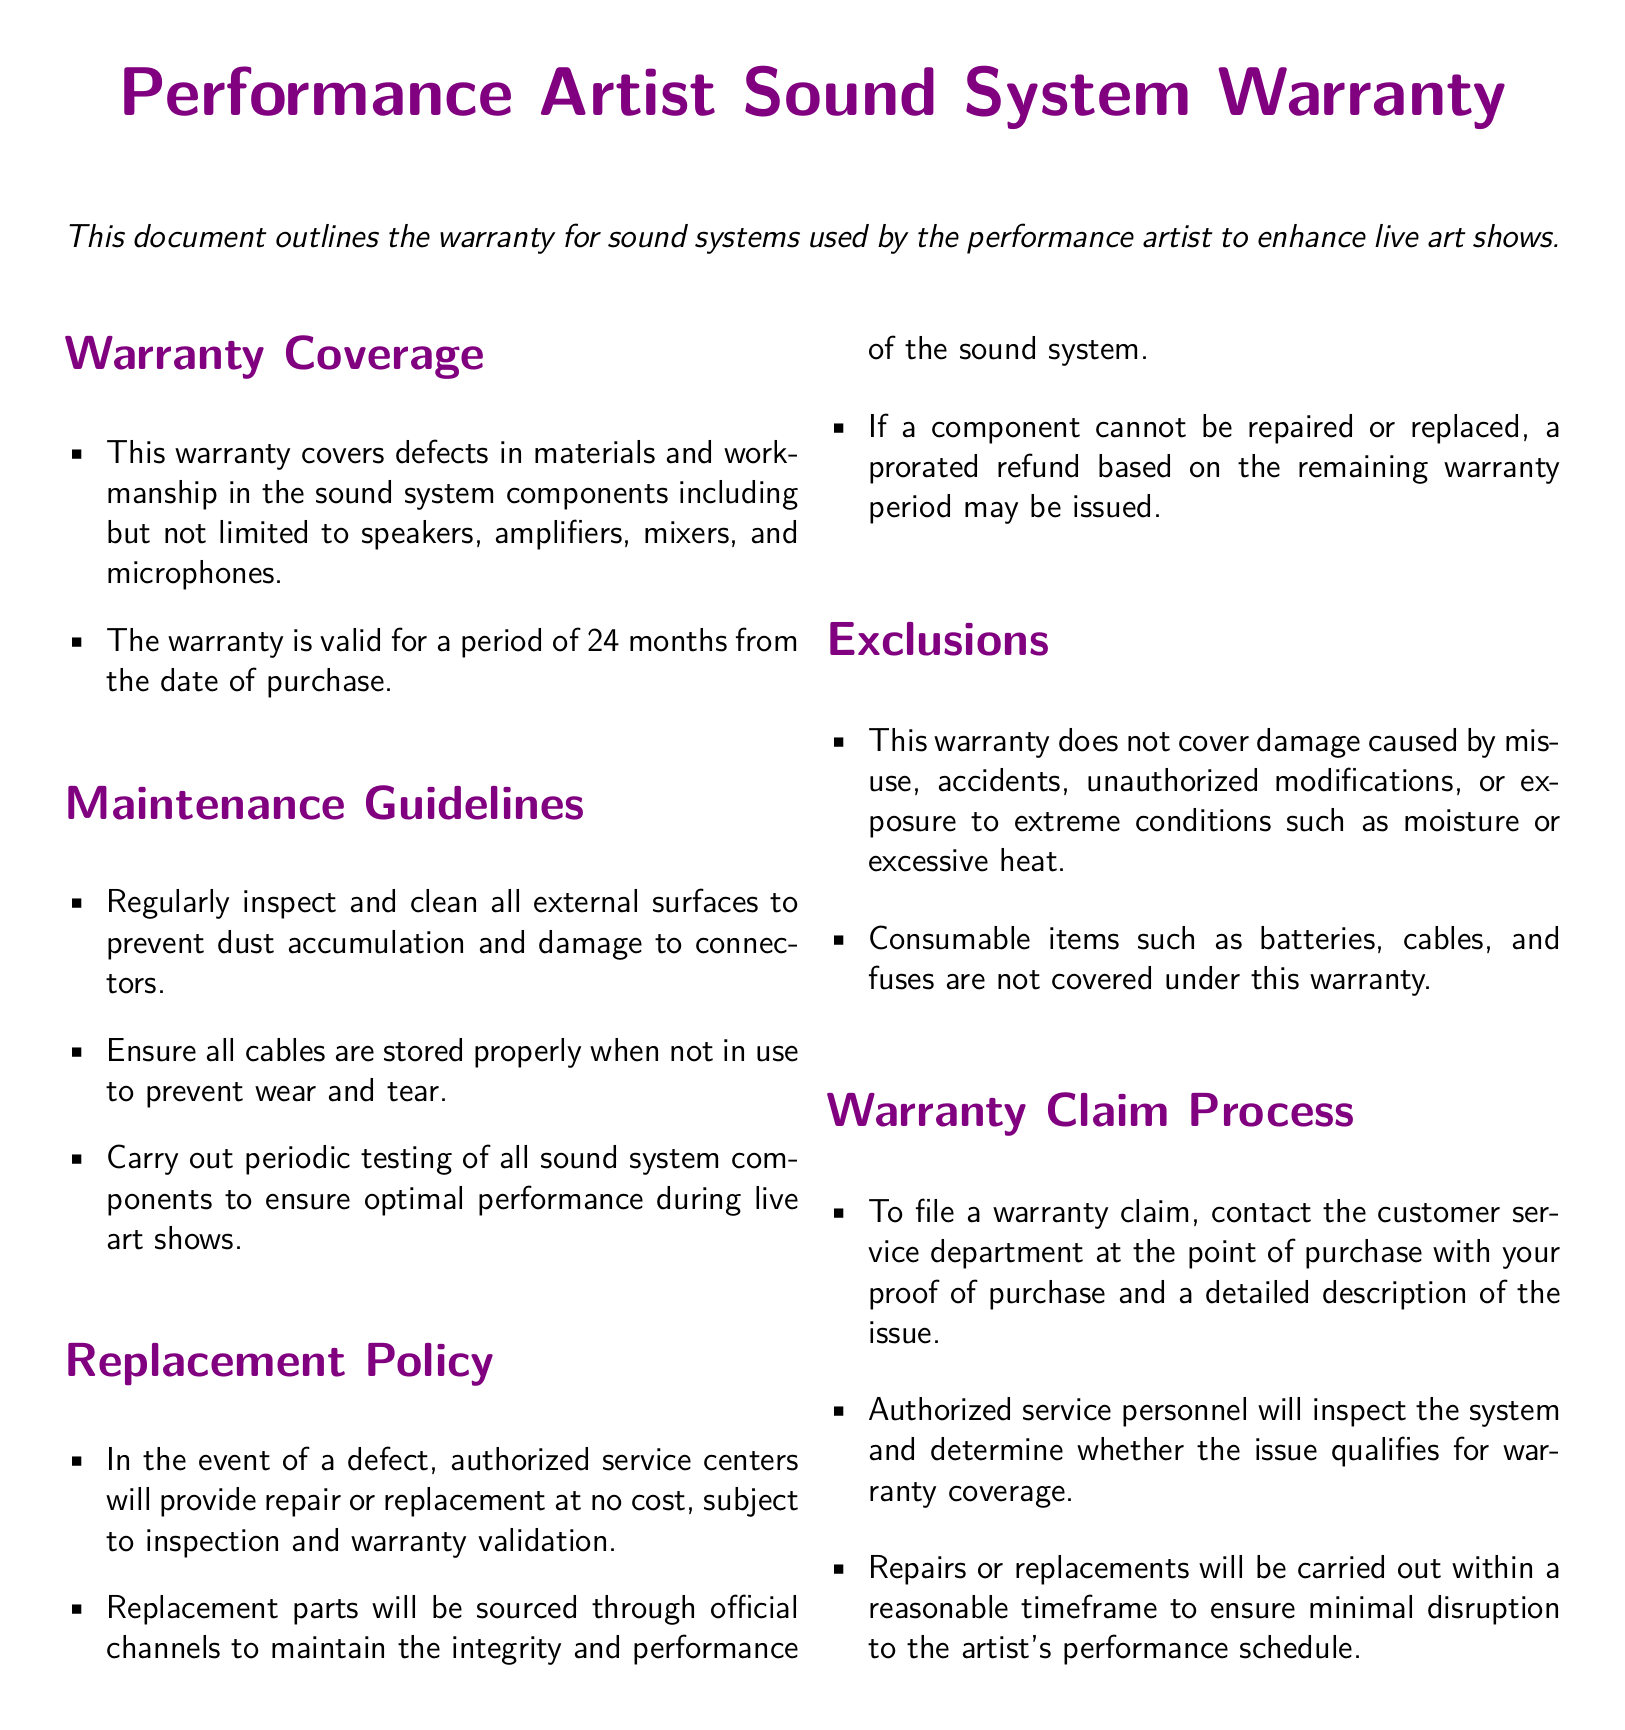What is the warranty period? The warranty is valid for a period of 24 months from the date of purchase.
Answer: 24 months What components are covered by the warranty? The warranty covers defects in materials and workmanship in components including speakers, amplifiers, mixers, and microphones.
Answer: Speakers, amplifiers, mixers, microphones What should be done to prevent damage to cables? Cables should be stored properly when not in use to prevent wear and tear.
Answer: Stored properly What happens if a component cannot be repaired? A prorated refund based on the remaining warranty period may be issued.
Answer: Prorated refund Who should claims be filed with? Claims should be filed with the customer service department at the point of purchase.
Answer: Customer service department What types of damages are excluded from the warranty? Damage caused by misuse, accidents, unauthorized modifications, or extreme conditions is excluded.
Answer: Misuse, accidents, unauthorized modifications, extreme conditions What is required to file a warranty claim? Proof of purchase and a detailed description of the issue is required.
Answer: Proof of purchase, description of the issue How often should sound system components be tested? Periodic testing of all sound system components should be carried out to ensure optimal performance.
Answer: Periodically What is the source for replacement parts? Replacement parts will be sourced through official channels to maintain integrity and performance.
Answer: Official channels 